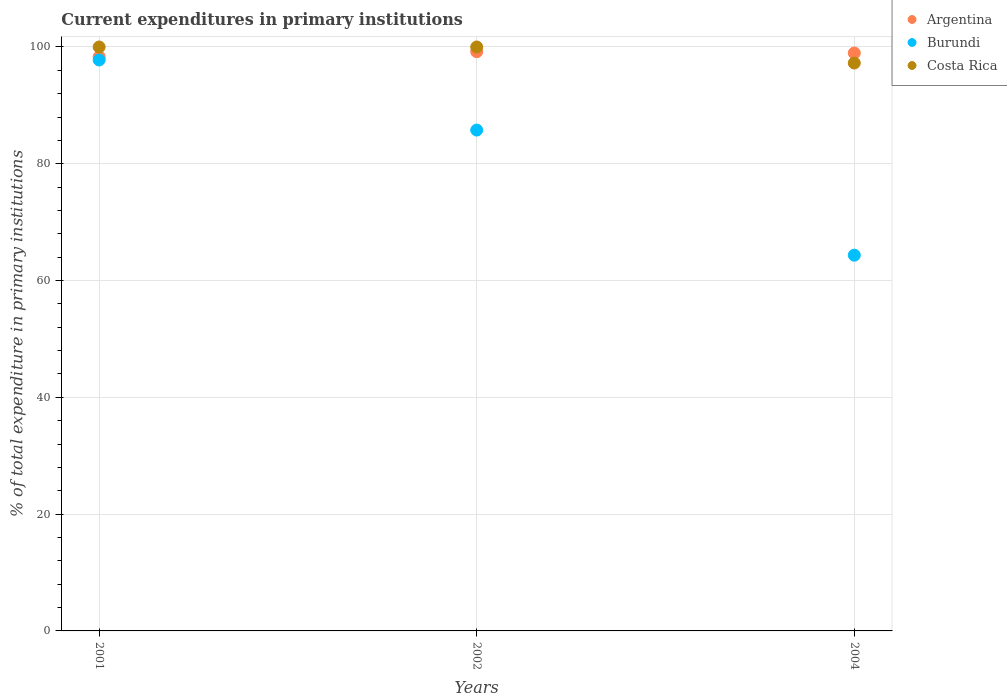What is the current expenditures in primary institutions in Argentina in 2002?
Your answer should be compact. 99.2. Across all years, what is the minimum current expenditures in primary institutions in Costa Rica?
Your answer should be very brief. 97.25. In which year was the current expenditures in primary institutions in Burundi maximum?
Give a very brief answer. 2001. What is the total current expenditures in primary institutions in Argentina in the graph?
Provide a short and direct response. 296.49. What is the difference between the current expenditures in primary institutions in Burundi in 2004 and the current expenditures in primary institutions in Costa Rica in 2001?
Your answer should be compact. -35.65. What is the average current expenditures in primary institutions in Burundi per year?
Provide a short and direct response. 82.63. In the year 2001, what is the difference between the current expenditures in primary institutions in Argentina and current expenditures in primary institutions in Costa Rica?
Your response must be concise. -1.67. What is the ratio of the current expenditures in primary institutions in Argentina in 2001 to that in 2004?
Offer a very short reply. 0.99. What is the difference between the highest and the lowest current expenditures in primary institutions in Argentina?
Ensure brevity in your answer.  0.87. How many dotlines are there?
Make the answer very short. 3. Does the graph contain grids?
Your answer should be very brief. Yes. How many legend labels are there?
Make the answer very short. 3. What is the title of the graph?
Ensure brevity in your answer.  Current expenditures in primary institutions. Does "Peru" appear as one of the legend labels in the graph?
Your response must be concise. No. What is the label or title of the Y-axis?
Your response must be concise. % of total expenditure in primary institutions. What is the % of total expenditure in primary institutions in Argentina in 2001?
Offer a very short reply. 98.33. What is the % of total expenditure in primary institutions in Burundi in 2001?
Provide a succinct answer. 97.77. What is the % of total expenditure in primary institutions of Argentina in 2002?
Ensure brevity in your answer.  99.2. What is the % of total expenditure in primary institutions of Burundi in 2002?
Provide a succinct answer. 85.77. What is the % of total expenditure in primary institutions in Argentina in 2004?
Your answer should be compact. 98.97. What is the % of total expenditure in primary institutions in Burundi in 2004?
Ensure brevity in your answer.  64.35. What is the % of total expenditure in primary institutions in Costa Rica in 2004?
Your answer should be very brief. 97.25. Across all years, what is the maximum % of total expenditure in primary institutions in Argentina?
Provide a short and direct response. 99.2. Across all years, what is the maximum % of total expenditure in primary institutions of Burundi?
Keep it short and to the point. 97.77. Across all years, what is the minimum % of total expenditure in primary institutions in Argentina?
Ensure brevity in your answer.  98.33. Across all years, what is the minimum % of total expenditure in primary institutions of Burundi?
Make the answer very short. 64.35. Across all years, what is the minimum % of total expenditure in primary institutions in Costa Rica?
Keep it short and to the point. 97.25. What is the total % of total expenditure in primary institutions in Argentina in the graph?
Offer a terse response. 296.49. What is the total % of total expenditure in primary institutions of Burundi in the graph?
Your answer should be very brief. 247.89. What is the total % of total expenditure in primary institutions of Costa Rica in the graph?
Make the answer very short. 297.25. What is the difference between the % of total expenditure in primary institutions of Argentina in 2001 and that in 2002?
Ensure brevity in your answer.  -0.87. What is the difference between the % of total expenditure in primary institutions in Burundi in 2001 and that in 2002?
Ensure brevity in your answer.  12. What is the difference between the % of total expenditure in primary institutions of Costa Rica in 2001 and that in 2002?
Offer a terse response. 0. What is the difference between the % of total expenditure in primary institutions of Argentina in 2001 and that in 2004?
Make the answer very short. -0.64. What is the difference between the % of total expenditure in primary institutions in Burundi in 2001 and that in 2004?
Provide a succinct answer. 33.43. What is the difference between the % of total expenditure in primary institutions of Costa Rica in 2001 and that in 2004?
Ensure brevity in your answer.  2.75. What is the difference between the % of total expenditure in primary institutions of Argentina in 2002 and that in 2004?
Offer a very short reply. 0.23. What is the difference between the % of total expenditure in primary institutions of Burundi in 2002 and that in 2004?
Ensure brevity in your answer.  21.42. What is the difference between the % of total expenditure in primary institutions of Costa Rica in 2002 and that in 2004?
Make the answer very short. 2.75. What is the difference between the % of total expenditure in primary institutions in Argentina in 2001 and the % of total expenditure in primary institutions in Burundi in 2002?
Your answer should be compact. 12.56. What is the difference between the % of total expenditure in primary institutions in Argentina in 2001 and the % of total expenditure in primary institutions in Costa Rica in 2002?
Make the answer very short. -1.67. What is the difference between the % of total expenditure in primary institutions in Burundi in 2001 and the % of total expenditure in primary institutions in Costa Rica in 2002?
Offer a very short reply. -2.23. What is the difference between the % of total expenditure in primary institutions of Argentina in 2001 and the % of total expenditure in primary institutions of Burundi in 2004?
Provide a short and direct response. 33.98. What is the difference between the % of total expenditure in primary institutions of Argentina in 2001 and the % of total expenditure in primary institutions of Costa Rica in 2004?
Ensure brevity in your answer.  1.08. What is the difference between the % of total expenditure in primary institutions of Burundi in 2001 and the % of total expenditure in primary institutions of Costa Rica in 2004?
Keep it short and to the point. 0.52. What is the difference between the % of total expenditure in primary institutions of Argentina in 2002 and the % of total expenditure in primary institutions of Burundi in 2004?
Provide a succinct answer. 34.85. What is the difference between the % of total expenditure in primary institutions in Argentina in 2002 and the % of total expenditure in primary institutions in Costa Rica in 2004?
Provide a short and direct response. 1.94. What is the difference between the % of total expenditure in primary institutions of Burundi in 2002 and the % of total expenditure in primary institutions of Costa Rica in 2004?
Provide a succinct answer. -11.48. What is the average % of total expenditure in primary institutions of Argentina per year?
Offer a very short reply. 98.83. What is the average % of total expenditure in primary institutions of Burundi per year?
Provide a succinct answer. 82.63. What is the average % of total expenditure in primary institutions of Costa Rica per year?
Your response must be concise. 99.08. In the year 2001, what is the difference between the % of total expenditure in primary institutions of Argentina and % of total expenditure in primary institutions of Burundi?
Keep it short and to the point. 0.55. In the year 2001, what is the difference between the % of total expenditure in primary institutions of Argentina and % of total expenditure in primary institutions of Costa Rica?
Keep it short and to the point. -1.67. In the year 2001, what is the difference between the % of total expenditure in primary institutions in Burundi and % of total expenditure in primary institutions in Costa Rica?
Keep it short and to the point. -2.23. In the year 2002, what is the difference between the % of total expenditure in primary institutions of Argentina and % of total expenditure in primary institutions of Burundi?
Make the answer very short. 13.42. In the year 2002, what is the difference between the % of total expenditure in primary institutions of Argentina and % of total expenditure in primary institutions of Costa Rica?
Provide a short and direct response. -0.8. In the year 2002, what is the difference between the % of total expenditure in primary institutions in Burundi and % of total expenditure in primary institutions in Costa Rica?
Your answer should be compact. -14.23. In the year 2004, what is the difference between the % of total expenditure in primary institutions of Argentina and % of total expenditure in primary institutions of Burundi?
Provide a succinct answer. 34.62. In the year 2004, what is the difference between the % of total expenditure in primary institutions in Argentina and % of total expenditure in primary institutions in Costa Rica?
Provide a succinct answer. 1.72. In the year 2004, what is the difference between the % of total expenditure in primary institutions in Burundi and % of total expenditure in primary institutions in Costa Rica?
Provide a succinct answer. -32.9. What is the ratio of the % of total expenditure in primary institutions of Burundi in 2001 to that in 2002?
Provide a short and direct response. 1.14. What is the ratio of the % of total expenditure in primary institutions of Costa Rica in 2001 to that in 2002?
Ensure brevity in your answer.  1. What is the ratio of the % of total expenditure in primary institutions in Burundi in 2001 to that in 2004?
Make the answer very short. 1.52. What is the ratio of the % of total expenditure in primary institutions of Costa Rica in 2001 to that in 2004?
Your response must be concise. 1.03. What is the ratio of the % of total expenditure in primary institutions of Argentina in 2002 to that in 2004?
Offer a very short reply. 1. What is the ratio of the % of total expenditure in primary institutions of Burundi in 2002 to that in 2004?
Your response must be concise. 1.33. What is the ratio of the % of total expenditure in primary institutions of Costa Rica in 2002 to that in 2004?
Provide a short and direct response. 1.03. What is the difference between the highest and the second highest % of total expenditure in primary institutions of Argentina?
Offer a terse response. 0.23. What is the difference between the highest and the second highest % of total expenditure in primary institutions of Burundi?
Your answer should be very brief. 12. What is the difference between the highest and the lowest % of total expenditure in primary institutions of Argentina?
Your answer should be compact. 0.87. What is the difference between the highest and the lowest % of total expenditure in primary institutions in Burundi?
Make the answer very short. 33.43. What is the difference between the highest and the lowest % of total expenditure in primary institutions of Costa Rica?
Your response must be concise. 2.75. 